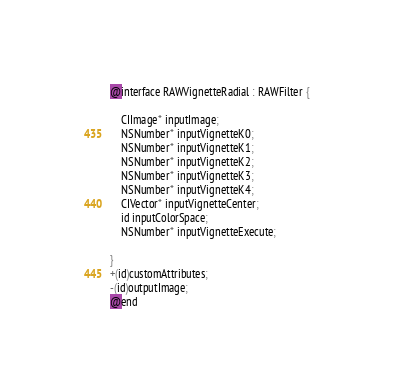Convert code to text. <code><loc_0><loc_0><loc_500><loc_500><_C_>
@interface RAWVignetteRadial : RAWFilter {

	CIImage* inputImage;
	NSNumber* inputVignetteK0;
	NSNumber* inputVignetteK1;
	NSNumber* inputVignetteK2;
	NSNumber* inputVignetteK3;
	NSNumber* inputVignetteK4;
	CIVector* inputVignetteCenter;
	id inputColorSpace;
	NSNumber* inputVignetteExecute;

}
+(id)customAttributes;
-(id)outputImage;
@end

</code> 